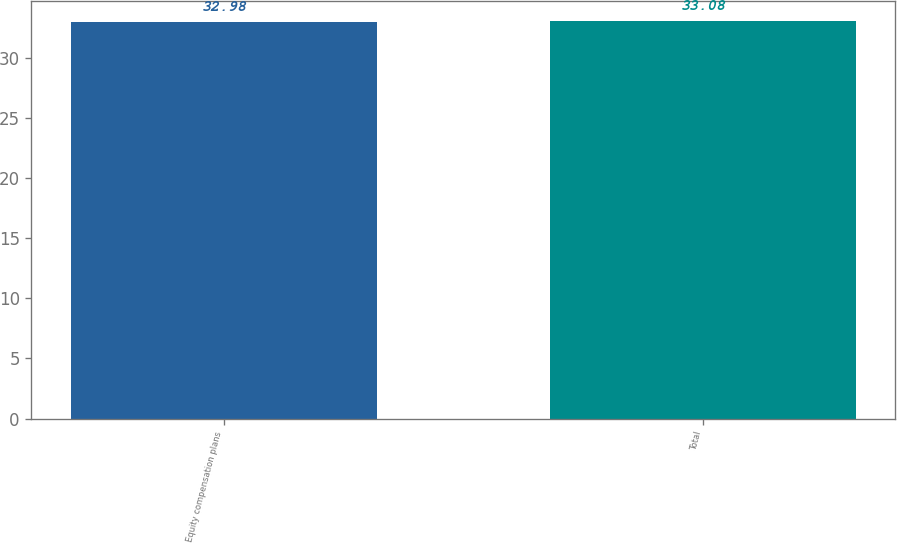<chart> <loc_0><loc_0><loc_500><loc_500><bar_chart><fcel>Equity compensation plans<fcel>Total<nl><fcel>32.98<fcel>33.08<nl></chart> 